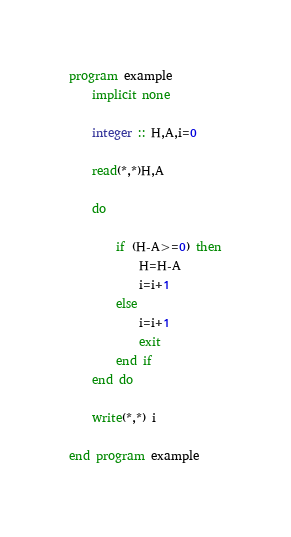<code> <loc_0><loc_0><loc_500><loc_500><_FORTRAN_>program example
	implicit none

	integer :: H,A,i=0
    
    read(*,*)H,A
    
    do 
    
    	if (H-A>=0) then
        	H=H-A
            i=i+1
        else
        	i=i+1
        	exit
        end if
    end do
    
    write(*,*) i

end program example</code> 